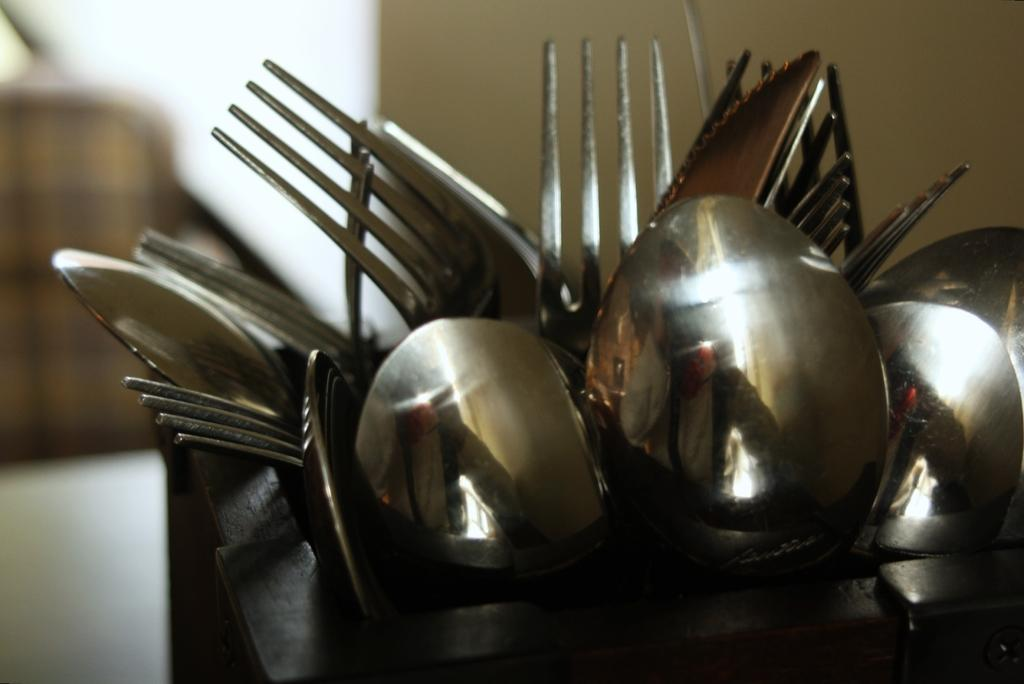What types of utensils are visible in the image? There are spoons and forks in the image. How are the spoons and forks arranged in the image? The spoons and forks are in a black color spoon stand. Can you describe the background of the image? The background of the image is blurred. What type of seed is growing on the aunt's toes in the image? There is no aunt or toes present in the image, and therefore no seed growing on them. 